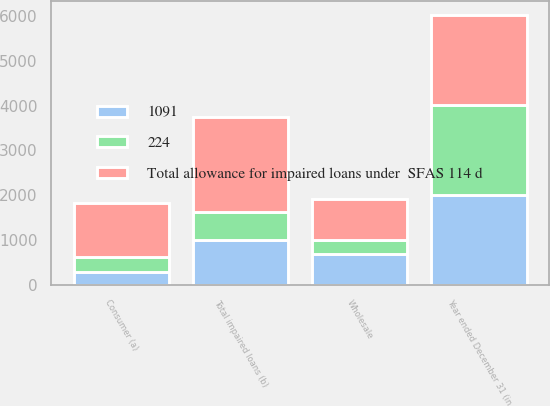Convert chart. <chart><loc_0><loc_0><loc_500><loc_500><stacked_bar_chart><ecel><fcel>Year ended December 31 (in<fcel>Wholesale<fcel>Consumer (a)<fcel>Total impaired loans (b)<nl><fcel>Total allowance for impaired loans under  SFAS 114 d<fcel>2008<fcel>896<fcel>1211<fcel>2107<nl><fcel>224<fcel>2007<fcel>316<fcel>317<fcel>633<nl><fcel>1091<fcel>2006<fcel>697<fcel>300<fcel>997<nl></chart> 